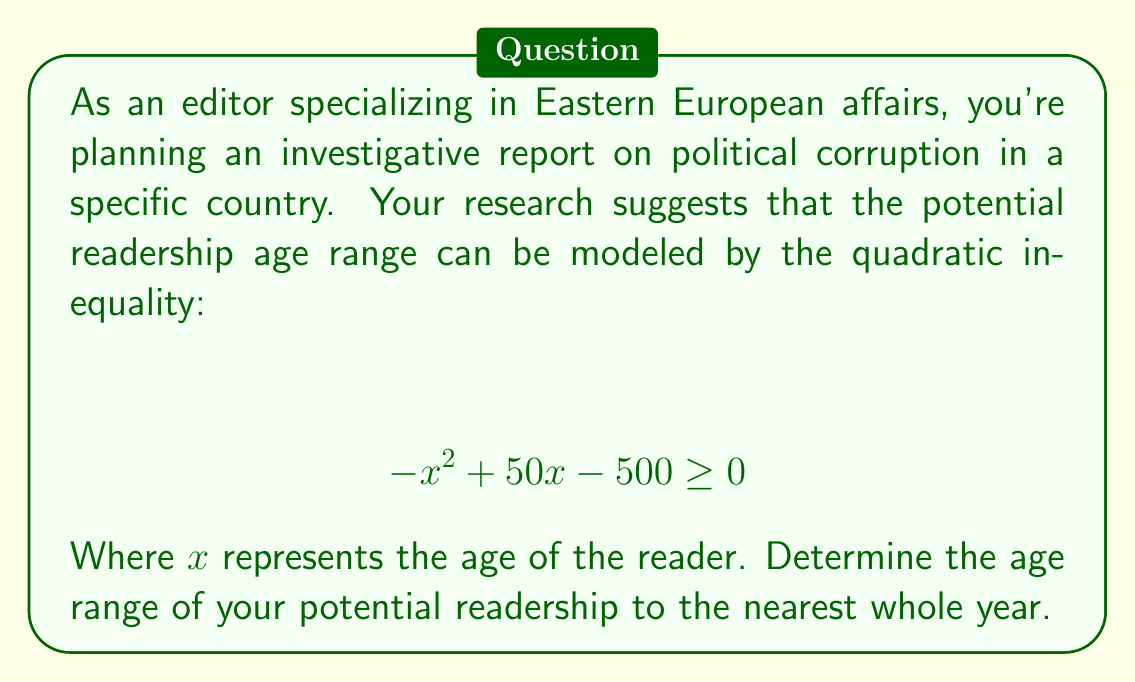Can you solve this math problem? To solve this quadratic inequality, we need to follow these steps:

1) First, we need to find the roots of the quadratic equation:
   $$ -x^2 + 50x - 500 = 0 $$

2) We can solve this using the quadratic formula: $x = \frac{-b \pm \sqrt{b^2 - 4ac}}{2a}$
   Where $a = -1$, $b = 50$, and $c = -500$

3) Plugging these values into the quadratic formula:
   $$ x = \frac{-50 \pm \sqrt{50^2 - 4(-1)(-500)}}{2(-1)} $$
   $$ x = \frac{-50 \pm \sqrt{2500 - 2000}}{-2} $$
   $$ x = \frac{-50 \pm \sqrt{500}}{-2} $$
   $$ x = \frac{-50 \pm 10\sqrt{5}}{-2} $$

4) Simplifying:
   $$ x = 25 \pm 5\sqrt{5} $$

5) This gives us two solutions:
   $x_1 = 25 + 5\sqrt{5} \approx 36.18$
   $x_2 = 25 - 5\sqrt{5} \approx 13.82$

6) Since the inequality is $\geq 0$, the solution includes all values between these two roots.

7) Rounding to the nearest whole year:
   The age range is from 14 to 36 years old.
Answer: The potential readership age range is 14 to 36 years old. 